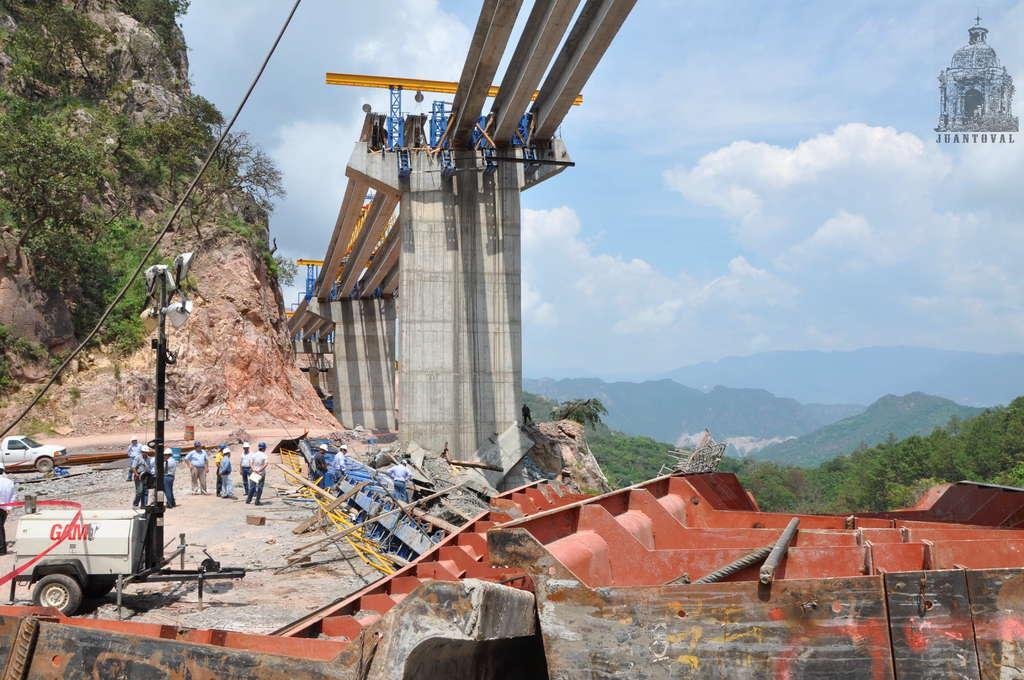Could you give a brief overview of what you see in this image? In this image I can see a construction site. On the left side of this image I can see few people are standing and I can also see vehicle. On the both side of this image I can see number of trees, clouds and the sky. I can also see a watermark on the top right corner of this image. I can also see a pole and few lights on the left side of this image. 